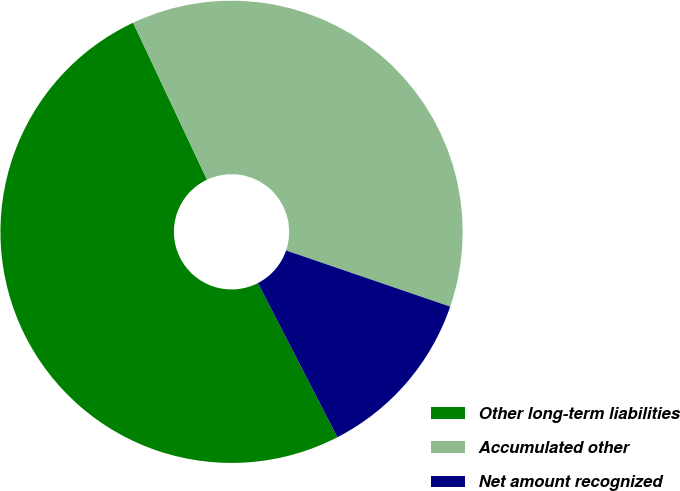<chart> <loc_0><loc_0><loc_500><loc_500><pie_chart><fcel>Other long-term liabilities<fcel>Accumulated other<fcel>Net amount recognized<nl><fcel>50.57%<fcel>37.25%<fcel>12.18%<nl></chart> 